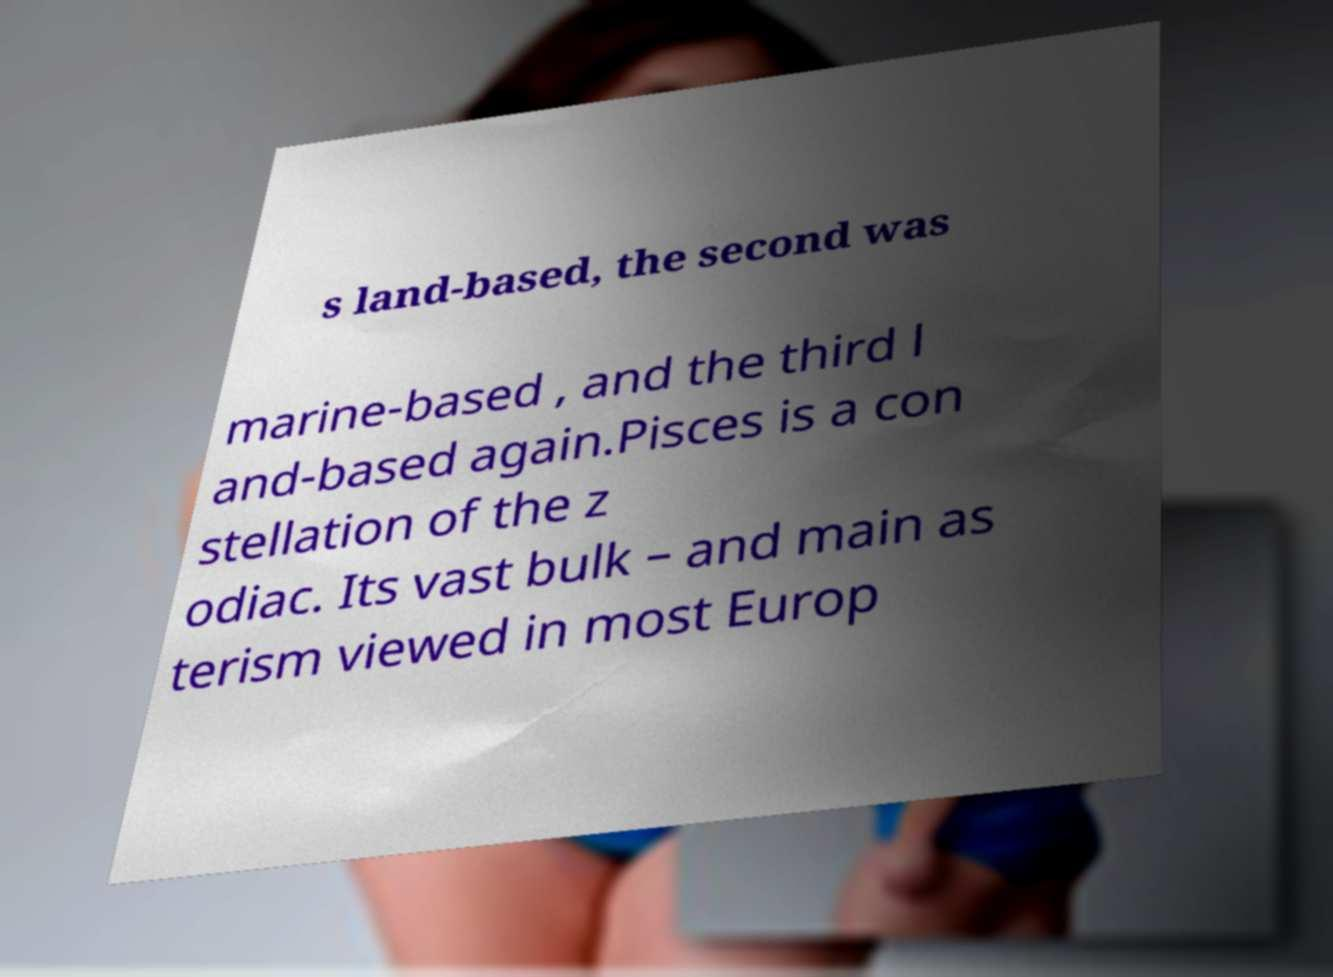There's text embedded in this image that I need extracted. Can you transcribe it verbatim? s land-based, the second was marine-based , and the third l and-based again.Pisces is a con stellation of the z odiac. Its vast bulk – and main as terism viewed in most Europ 